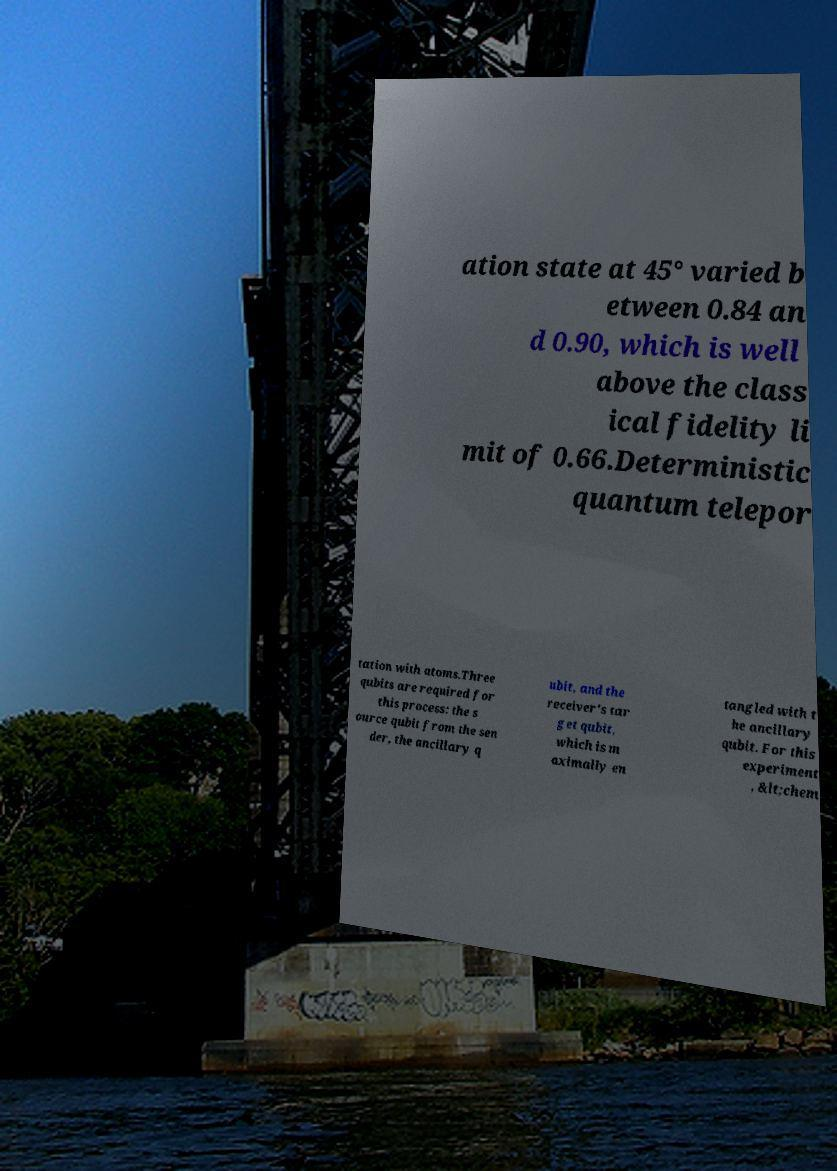Can you accurately transcribe the text from the provided image for me? ation state at 45° varied b etween 0.84 an d 0.90, which is well above the class ical fidelity li mit of 0.66.Deterministic quantum telepor tation with atoms.Three qubits are required for this process: the s ource qubit from the sen der, the ancillary q ubit, and the receiver's tar get qubit, which is m aximally en tangled with t he ancillary qubit. For this experiment , &lt;chem 